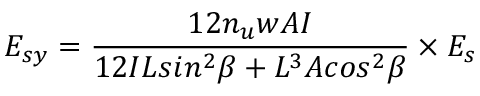Convert formula to latex. <formula><loc_0><loc_0><loc_500><loc_500>E _ { s y } = \frac { 1 2 n _ { u } w A I } { 1 2 I L \sin ^ { 2 } \beta + L ^ { 3 } A \cos ^ { 2 } \beta } \times { E _ { s } }</formula> 